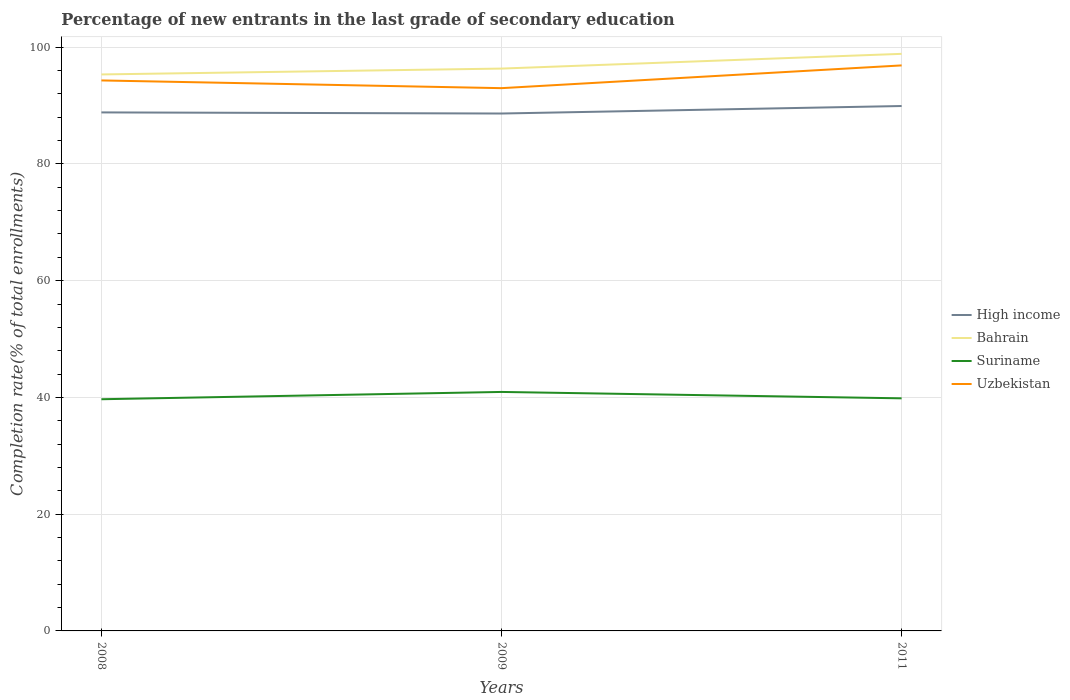How many different coloured lines are there?
Ensure brevity in your answer.  4. Across all years, what is the maximum percentage of new entrants in High income?
Offer a terse response. 88.63. What is the total percentage of new entrants in Uzbekistan in the graph?
Offer a terse response. -3.9. What is the difference between the highest and the second highest percentage of new entrants in High income?
Provide a short and direct response. 1.28. What is the difference between the highest and the lowest percentage of new entrants in High income?
Provide a short and direct response. 1. Is the percentage of new entrants in Bahrain strictly greater than the percentage of new entrants in Uzbekistan over the years?
Provide a short and direct response. No. How many lines are there?
Offer a terse response. 4. Are the values on the major ticks of Y-axis written in scientific E-notation?
Keep it short and to the point. No. Does the graph contain grids?
Ensure brevity in your answer.  Yes. Where does the legend appear in the graph?
Provide a short and direct response. Center right. How are the legend labels stacked?
Your answer should be compact. Vertical. What is the title of the graph?
Ensure brevity in your answer.  Percentage of new entrants in the last grade of secondary education. What is the label or title of the Y-axis?
Provide a succinct answer. Completion rate(% of total enrollments). What is the Completion rate(% of total enrollments) of High income in 2008?
Make the answer very short. 88.82. What is the Completion rate(% of total enrollments) in Bahrain in 2008?
Make the answer very short. 95.33. What is the Completion rate(% of total enrollments) in Suriname in 2008?
Offer a very short reply. 39.69. What is the Completion rate(% of total enrollments) of Uzbekistan in 2008?
Give a very brief answer. 94.3. What is the Completion rate(% of total enrollments) in High income in 2009?
Ensure brevity in your answer.  88.63. What is the Completion rate(% of total enrollments) in Bahrain in 2009?
Your answer should be very brief. 96.33. What is the Completion rate(% of total enrollments) of Suriname in 2009?
Offer a very short reply. 40.94. What is the Completion rate(% of total enrollments) of Uzbekistan in 2009?
Give a very brief answer. 92.98. What is the Completion rate(% of total enrollments) in High income in 2011?
Provide a succinct answer. 89.92. What is the Completion rate(% of total enrollments) in Bahrain in 2011?
Offer a terse response. 98.86. What is the Completion rate(% of total enrollments) in Suriname in 2011?
Keep it short and to the point. 39.84. What is the Completion rate(% of total enrollments) of Uzbekistan in 2011?
Offer a terse response. 96.87. Across all years, what is the maximum Completion rate(% of total enrollments) in High income?
Make the answer very short. 89.92. Across all years, what is the maximum Completion rate(% of total enrollments) in Bahrain?
Your answer should be compact. 98.86. Across all years, what is the maximum Completion rate(% of total enrollments) in Suriname?
Offer a terse response. 40.94. Across all years, what is the maximum Completion rate(% of total enrollments) of Uzbekistan?
Provide a short and direct response. 96.87. Across all years, what is the minimum Completion rate(% of total enrollments) of High income?
Provide a succinct answer. 88.63. Across all years, what is the minimum Completion rate(% of total enrollments) in Bahrain?
Keep it short and to the point. 95.33. Across all years, what is the minimum Completion rate(% of total enrollments) of Suriname?
Your answer should be very brief. 39.69. Across all years, what is the minimum Completion rate(% of total enrollments) of Uzbekistan?
Provide a succinct answer. 92.98. What is the total Completion rate(% of total enrollments) of High income in the graph?
Give a very brief answer. 267.37. What is the total Completion rate(% of total enrollments) of Bahrain in the graph?
Give a very brief answer. 290.51. What is the total Completion rate(% of total enrollments) of Suriname in the graph?
Make the answer very short. 120.47. What is the total Completion rate(% of total enrollments) in Uzbekistan in the graph?
Provide a succinct answer. 284.15. What is the difference between the Completion rate(% of total enrollments) in High income in 2008 and that in 2009?
Give a very brief answer. 0.19. What is the difference between the Completion rate(% of total enrollments) in Bahrain in 2008 and that in 2009?
Your response must be concise. -1. What is the difference between the Completion rate(% of total enrollments) in Suriname in 2008 and that in 2009?
Your answer should be compact. -1.25. What is the difference between the Completion rate(% of total enrollments) of Uzbekistan in 2008 and that in 2009?
Keep it short and to the point. 1.32. What is the difference between the Completion rate(% of total enrollments) of High income in 2008 and that in 2011?
Your answer should be compact. -1.09. What is the difference between the Completion rate(% of total enrollments) of Bahrain in 2008 and that in 2011?
Offer a very short reply. -3.53. What is the difference between the Completion rate(% of total enrollments) of Suriname in 2008 and that in 2011?
Give a very brief answer. -0.16. What is the difference between the Completion rate(% of total enrollments) in Uzbekistan in 2008 and that in 2011?
Keep it short and to the point. -2.57. What is the difference between the Completion rate(% of total enrollments) of High income in 2009 and that in 2011?
Offer a very short reply. -1.28. What is the difference between the Completion rate(% of total enrollments) in Bahrain in 2009 and that in 2011?
Give a very brief answer. -2.52. What is the difference between the Completion rate(% of total enrollments) of Suriname in 2009 and that in 2011?
Give a very brief answer. 1.09. What is the difference between the Completion rate(% of total enrollments) of Uzbekistan in 2009 and that in 2011?
Keep it short and to the point. -3.9. What is the difference between the Completion rate(% of total enrollments) in High income in 2008 and the Completion rate(% of total enrollments) in Bahrain in 2009?
Keep it short and to the point. -7.51. What is the difference between the Completion rate(% of total enrollments) of High income in 2008 and the Completion rate(% of total enrollments) of Suriname in 2009?
Provide a short and direct response. 47.88. What is the difference between the Completion rate(% of total enrollments) in High income in 2008 and the Completion rate(% of total enrollments) in Uzbekistan in 2009?
Your answer should be very brief. -4.15. What is the difference between the Completion rate(% of total enrollments) of Bahrain in 2008 and the Completion rate(% of total enrollments) of Suriname in 2009?
Your answer should be compact. 54.39. What is the difference between the Completion rate(% of total enrollments) in Bahrain in 2008 and the Completion rate(% of total enrollments) in Uzbekistan in 2009?
Offer a terse response. 2.35. What is the difference between the Completion rate(% of total enrollments) of Suriname in 2008 and the Completion rate(% of total enrollments) of Uzbekistan in 2009?
Keep it short and to the point. -53.29. What is the difference between the Completion rate(% of total enrollments) of High income in 2008 and the Completion rate(% of total enrollments) of Bahrain in 2011?
Ensure brevity in your answer.  -10.03. What is the difference between the Completion rate(% of total enrollments) of High income in 2008 and the Completion rate(% of total enrollments) of Suriname in 2011?
Your response must be concise. 48.98. What is the difference between the Completion rate(% of total enrollments) of High income in 2008 and the Completion rate(% of total enrollments) of Uzbekistan in 2011?
Keep it short and to the point. -8.05. What is the difference between the Completion rate(% of total enrollments) in Bahrain in 2008 and the Completion rate(% of total enrollments) in Suriname in 2011?
Keep it short and to the point. 55.48. What is the difference between the Completion rate(% of total enrollments) of Bahrain in 2008 and the Completion rate(% of total enrollments) of Uzbekistan in 2011?
Keep it short and to the point. -1.55. What is the difference between the Completion rate(% of total enrollments) in Suriname in 2008 and the Completion rate(% of total enrollments) in Uzbekistan in 2011?
Keep it short and to the point. -57.19. What is the difference between the Completion rate(% of total enrollments) of High income in 2009 and the Completion rate(% of total enrollments) of Bahrain in 2011?
Your response must be concise. -10.22. What is the difference between the Completion rate(% of total enrollments) of High income in 2009 and the Completion rate(% of total enrollments) of Suriname in 2011?
Offer a terse response. 48.79. What is the difference between the Completion rate(% of total enrollments) of High income in 2009 and the Completion rate(% of total enrollments) of Uzbekistan in 2011?
Your answer should be very brief. -8.24. What is the difference between the Completion rate(% of total enrollments) in Bahrain in 2009 and the Completion rate(% of total enrollments) in Suriname in 2011?
Keep it short and to the point. 56.49. What is the difference between the Completion rate(% of total enrollments) of Bahrain in 2009 and the Completion rate(% of total enrollments) of Uzbekistan in 2011?
Make the answer very short. -0.54. What is the difference between the Completion rate(% of total enrollments) of Suriname in 2009 and the Completion rate(% of total enrollments) of Uzbekistan in 2011?
Keep it short and to the point. -55.94. What is the average Completion rate(% of total enrollments) of High income per year?
Give a very brief answer. 89.12. What is the average Completion rate(% of total enrollments) in Bahrain per year?
Your answer should be compact. 96.84. What is the average Completion rate(% of total enrollments) of Suriname per year?
Make the answer very short. 40.16. What is the average Completion rate(% of total enrollments) of Uzbekistan per year?
Your answer should be very brief. 94.72. In the year 2008, what is the difference between the Completion rate(% of total enrollments) in High income and Completion rate(% of total enrollments) in Bahrain?
Keep it short and to the point. -6.5. In the year 2008, what is the difference between the Completion rate(% of total enrollments) in High income and Completion rate(% of total enrollments) in Suriname?
Keep it short and to the point. 49.13. In the year 2008, what is the difference between the Completion rate(% of total enrollments) of High income and Completion rate(% of total enrollments) of Uzbekistan?
Your response must be concise. -5.48. In the year 2008, what is the difference between the Completion rate(% of total enrollments) of Bahrain and Completion rate(% of total enrollments) of Suriname?
Ensure brevity in your answer.  55.64. In the year 2008, what is the difference between the Completion rate(% of total enrollments) in Bahrain and Completion rate(% of total enrollments) in Uzbekistan?
Offer a very short reply. 1.03. In the year 2008, what is the difference between the Completion rate(% of total enrollments) of Suriname and Completion rate(% of total enrollments) of Uzbekistan?
Your answer should be compact. -54.61. In the year 2009, what is the difference between the Completion rate(% of total enrollments) in High income and Completion rate(% of total enrollments) in Bahrain?
Offer a very short reply. -7.7. In the year 2009, what is the difference between the Completion rate(% of total enrollments) in High income and Completion rate(% of total enrollments) in Suriname?
Your answer should be compact. 47.7. In the year 2009, what is the difference between the Completion rate(% of total enrollments) of High income and Completion rate(% of total enrollments) of Uzbekistan?
Offer a very short reply. -4.34. In the year 2009, what is the difference between the Completion rate(% of total enrollments) in Bahrain and Completion rate(% of total enrollments) in Suriname?
Your response must be concise. 55.39. In the year 2009, what is the difference between the Completion rate(% of total enrollments) in Bahrain and Completion rate(% of total enrollments) in Uzbekistan?
Give a very brief answer. 3.35. In the year 2009, what is the difference between the Completion rate(% of total enrollments) in Suriname and Completion rate(% of total enrollments) in Uzbekistan?
Give a very brief answer. -52.04. In the year 2011, what is the difference between the Completion rate(% of total enrollments) of High income and Completion rate(% of total enrollments) of Bahrain?
Your answer should be compact. -8.94. In the year 2011, what is the difference between the Completion rate(% of total enrollments) of High income and Completion rate(% of total enrollments) of Suriname?
Make the answer very short. 50.07. In the year 2011, what is the difference between the Completion rate(% of total enrollments) of High income and Completion rate(% of total enrollments) of Uzbekistan?
Your answer should be very brief. -6.96. In the year 2011, what is the difference between the Completion rate(% of total enrollments) of Bahrain and Completion rate(% of total enrollments) of Suriname?
Your response must be concise. 59.01. In the year 2011, what is the difference between the Completion rate(% of total enrollments) in Bahrain and Completion rate(% of total enrollments) in Uzbekistan?
Your response must be concise. 1.98. In the year 2011, what is the difference between the Completion rate(% of total enrollments) of Suriname and Completion rate(% of total enrollments) of Uzbekistan?
Your response must be concise. -57.03. What is the ratio of the Completion rate(% of total enrollments) of High income in 2008 to that in 2009?
Your answer should be compact. 1. What is the ratio of the Completion rate(% of total enrollments) in Suriname in 2008 to that in 2009?
Your response must be concise. 0.97. What is the ratio of the Completion rate(% of total enrollments) of Uzbekistan in 2008 to that in 2009?
Your response must be concise. 1.01. What is the ratio of the Completion rate(% of total enrollments) in Uzbekistan in 2008 to that in 2011?
Offer a very short reply. 0.97. What is the ratio of the Completion rate(% of total enrollments) of High income in 2009 to that in 2011?
Give a very brief answer. 0.99. What is the ratio of the Completion rate(% of total enrollments) in Bahrain in 2009 to that in 2011?
Your answer should be compact. 0.97. What is the ratio of the Completion rate(% of total enrollments) of Suriname in 2009 to that in 2011?
Give a very brief answer. 1.03. What is the ratio of the Completion rate(% of total enrollments) of Uzbekistan in 2009 to that in 2011?
Provide a short and direct response. 0.96. What is the difference between the highest and the second highest Completion rate(% of total enrollments) in High income?
Give a very brief answer. 1.09. What is the difference between the highest and the second highest Completion rate(% of total enrollments) in Bahrain?
Provide a succinct answer. 2.52. What is the difference between the highest and the second highest Completion rate(% of total enrollments) of Suriname?
Your answer should be compact. 1.09. What is the difference between the highest and the second highest Completion rate(% of total enrollments) in Uzbekistan?
Your answer should be very brief. 2.57. What is the difference between the highest and the lowest Completion rate(% of total enrollments) of High income?
Provide a short and direct response. 1.28. What is the difference between the highest and the lowest Completion rate(% of total enrollments) of Bahrain?
Give a very brief answer. 3.53. What is the difference between the highest and the lowest Completion rate(% of total enrollments) in Suriname?
Keep it short and to the point. 1.25. What is the difference between the highest and the lowest Completion rate(% of total enrollments) in Uzbekistan?
Provide a succinct answer. 3.9. 